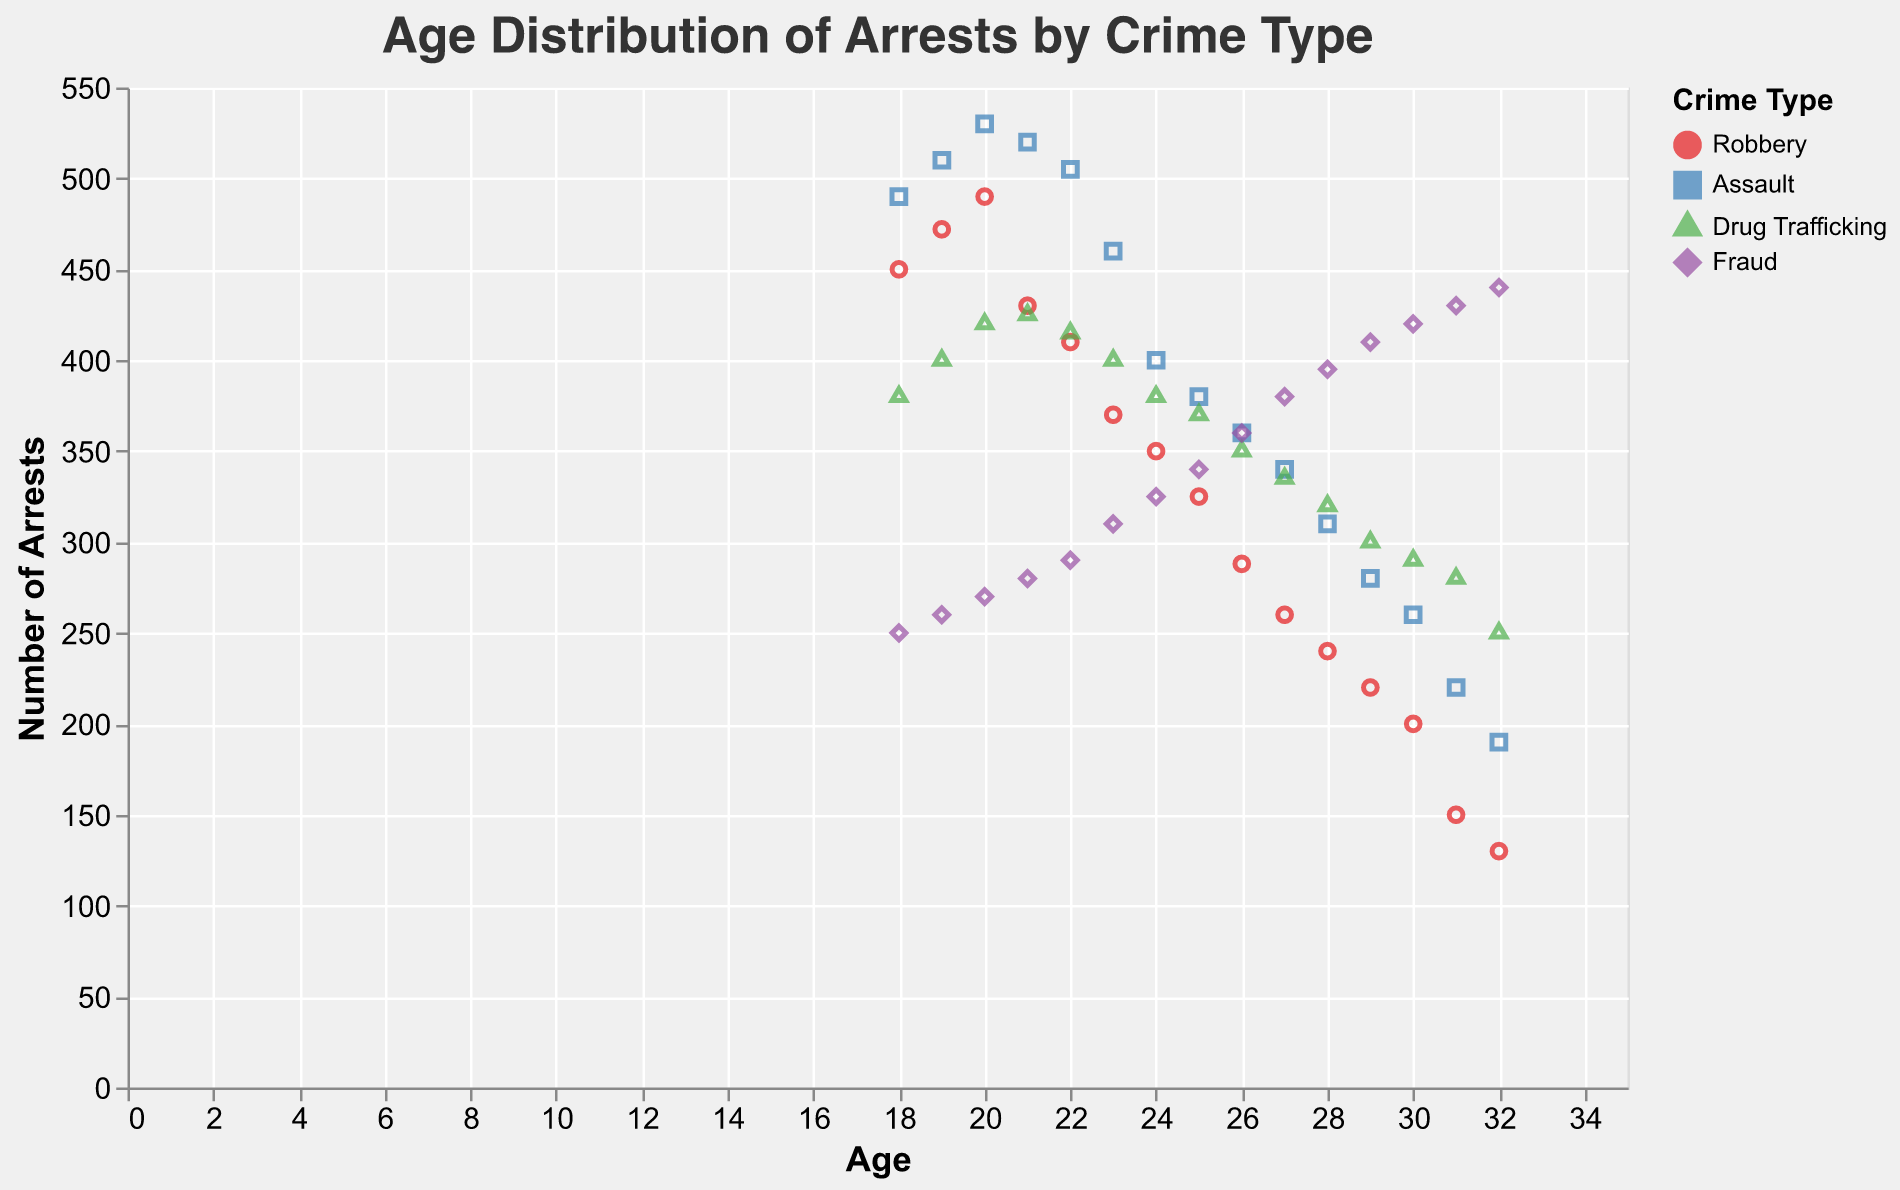What is the title of the plot? The title is displayed at the top of the plot. It reads "Age Distribution of Arrests by Crime Type".
Answer: Age Distribution of Arrests by Crime Type What is the age at which most arrests for robbery occur? Referring to the plot, the highest point for robbery is at age 20 with 490 arrests.
Answer: 20 Which crime type has the highest number of arrests at age 28? Looking at the points corresponding to age 28, Assault has the highest number of arrests with 310.
Answer: Assault How do the arrests for robbery change from age 18 to age 32? Observe the trend line for Robbery. It starts at 450 arrests at age 18 and gradually decreases to around 130 arrests by age 32.
Answer: Decreases What is the overall trend for arrests in Assault? The trend line for Assault initially increases from age 18 to age 21, then shows a steady decline from age 22 to age 32.
Answer: Increases initially and then decreases Which crime type increases in arrests as age increases? Fraud is the only crime type that shows a steady increase in the number of arrests as age increases.
Answer: Fraud At what age do arrests for Drug Trafficking peak? Looking at the points for Drug Trafficking, arrests peak at age 21 with 425 arrests.
Answer: 21 Compare the number of arrests for Fraud and Robbery at age 24. Which is higher? At age 24, Fraud has 325 arrests while Robbery has 350 arrests.
Answer: Robbery Which age has the most arrests overall across all crime types? By checking the y-axis, age 20 has the highest combined arrests: 490 (Robbery), 530 (Assault), 420 (Drug Trafficking), and 270 (Fraud).
Answer: 20 Describe the shape encoding for each crime type in the plot. The plot uses different shapes for each crime type: circle for Robbery, square for Assault, triangle for Drug Trafficking, and diamond for Fraud.
Answer: Robbery: circle, Assault: square, Drug Trafficking: triangle, Fraud: diamond 